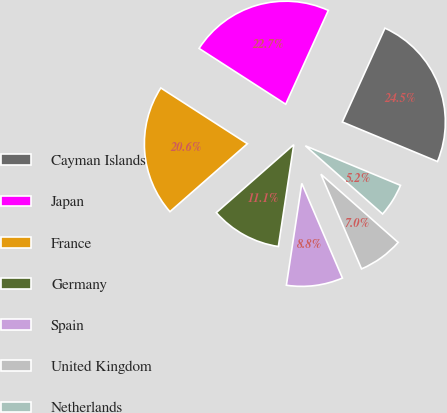<chart> <loc_0><loc_0><loc_500><loc_500><pie_chart><fcel>Cayman Islands<fcel>Japan<fcel>France<fcel>Germany<fcel>Spain<fcel>United Kingdom<fcel>Netherlands<nl><fcel>24.48%<fcel>22.68%<fcel>20.57%<fcel>11.15%<fcel>8.84%<fcel>7.04%<fcel>5.24%<nl></chart> 